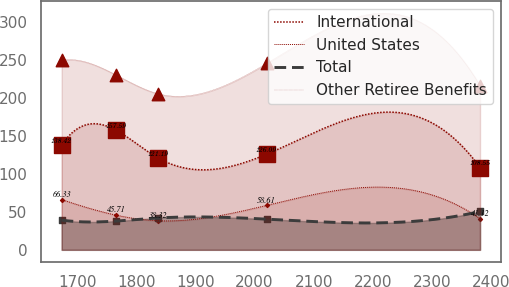Convert chart to OTSL. <chart><loc_0><loc_0><loc_500><loc_500><line_chart><ecel><fcel>International<fcel>United States<fcel>Total<fcel>Other Retiree Benefits<nl><fcel>1673.46<fcel>138.42<fcel>66.33<fcel>39.22<fcel>250.15<nl><fcel>1765.75<fcel>157.59<fcel>45.71<fcel>37.95<fcel>230.53<nl><fcel>1836.56<fcel>121.19<fcel>38.32<fcel>42.01<fcel>205.87<nl><fcel>2020.36<fcel>126.09<fcel>58.61<fcel>40.49<fcel>245.91<nl><fcel>2381.58<fcel>108.55<fcel>41.12<fcel>50.66<fcel>216.48<nl></chart> 